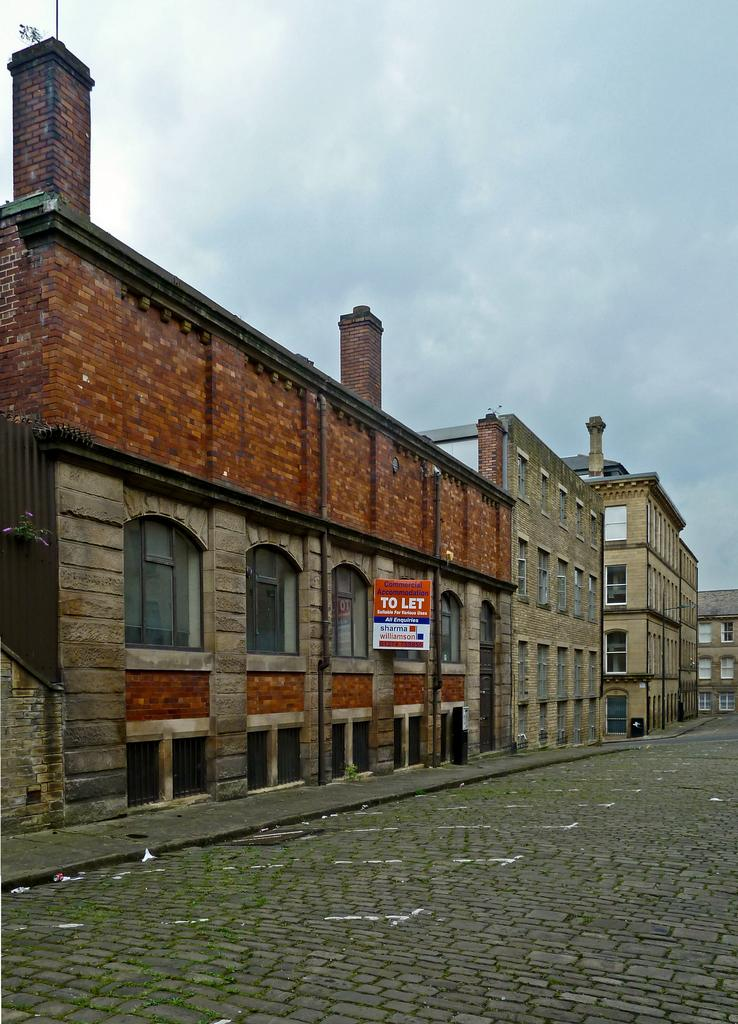What type of structures can be seen in the image? There are buildings in the image. What object is present in the image besides the buildings? There is a board in the image. What can be seen in the background of the image? The sky is visible in the background of the image. What is the condition of the sky in the image? Clouds are present in the sky. What type of behavior can be observed in the beef pies in the image? There are no beef pies present in the image, so it is not possible to observe any behavior. 